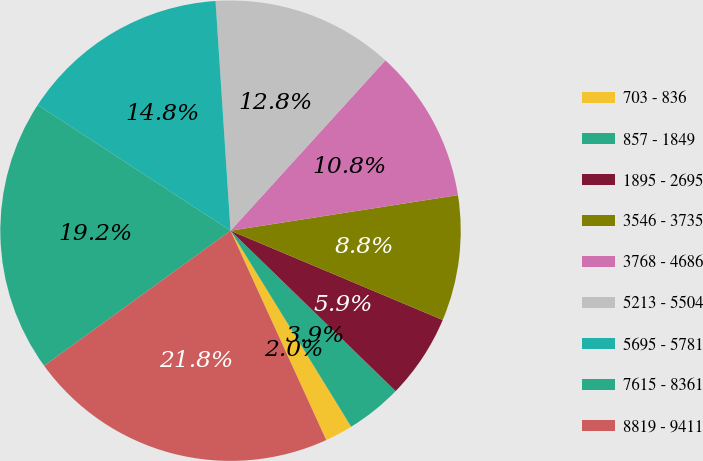Convert chart. <chart><loc_0><loc_0><loc_500><loc_500><pie_chart><fcel>703 - 836<fcel>857 - 1849<fcel>1895 - 2695<fcel>3546 - 3735<fcel>3768 - 4686<fcel>5213 - 5504<fcel>5695 - 5781<fcel>7615 - 8361<fcel>8819 - 9411<nl><fcel>1.96%<fcel>3.95%<fcel>5.93%<fcel>8.81%<fcel>10.79%<fcel>12.78%<fcel>14.77%<fcel>19.18%<fcel>21.84%<nl></chart> 